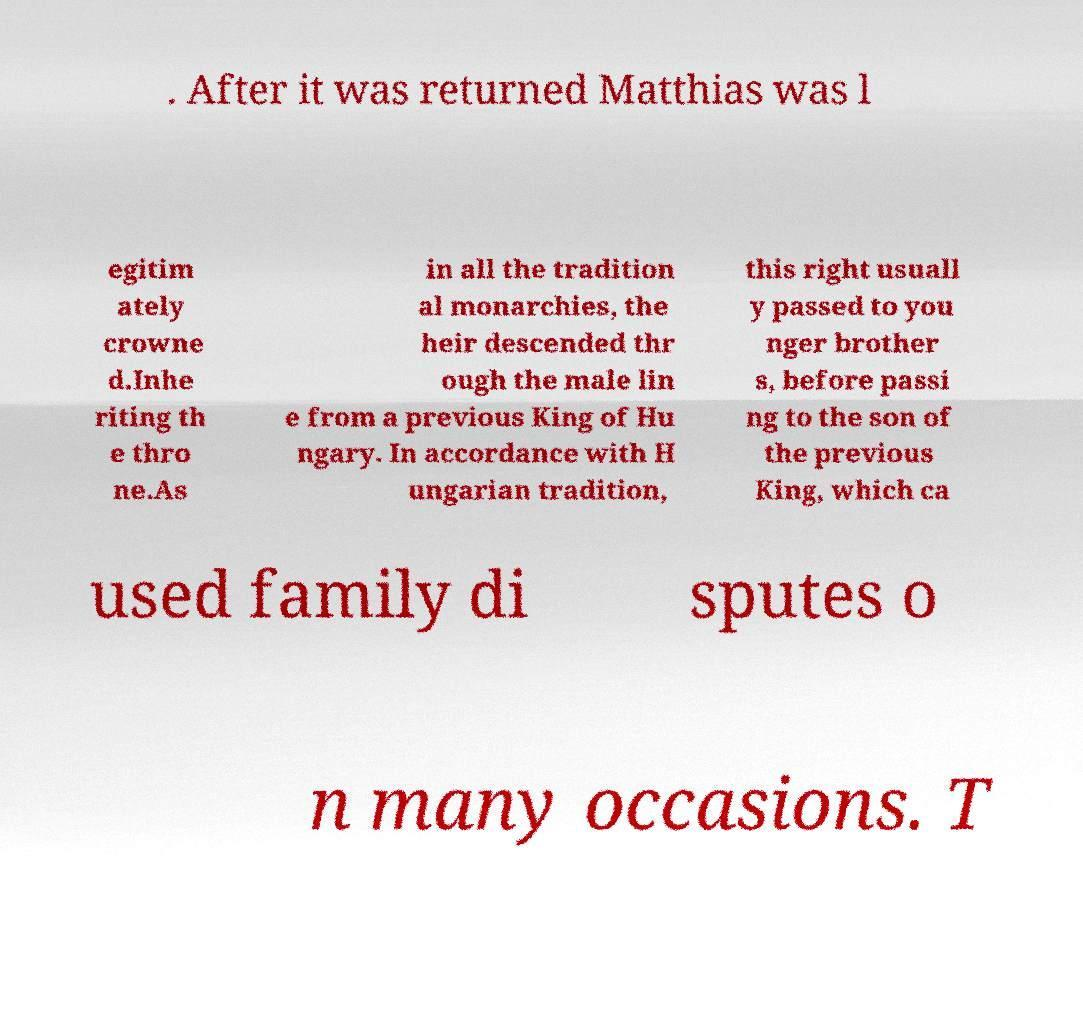Can you read and provide the text displayed in the image?This photo seems to have some interesting text. Can you extract and type it out for me? . After it was returned Matthias was l egitim ately crowne d.Inhe riting th e thro ne.As in all the tradition al monarchies, the heir descended thr ough the male lin e from a previous King of Hu ngary. In accordance with H ungarian tradition, this right usuall y passed to you nger brother s, before passi ng to the son of the previous King, which ca used family di sputes o n many occasions. T 